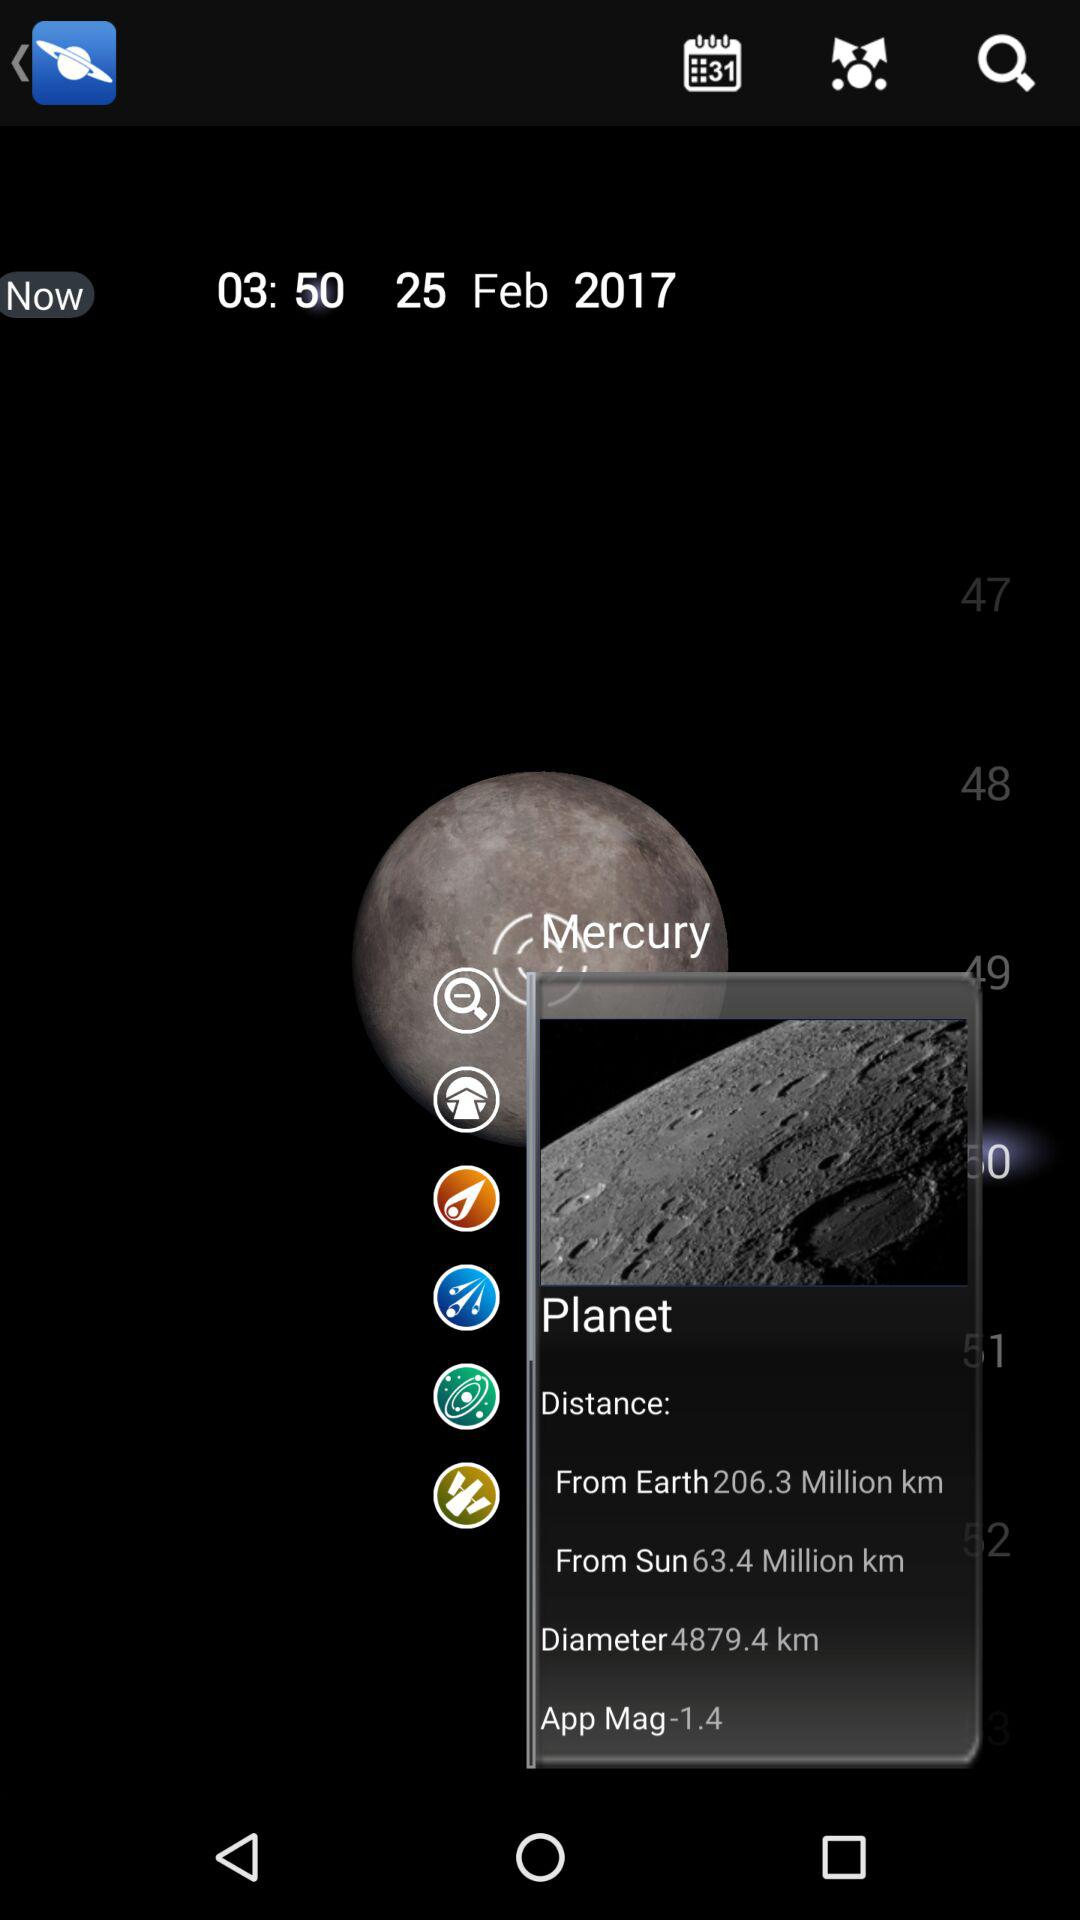What is the selected time? The selected time is 03:50. 